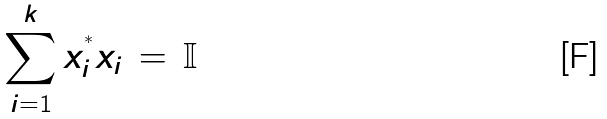<formula> <loc_0><loc_0><loc_500><loc_500>\sum _ { i = 1 } ^ { k } x _ { i } ^ { ^ { * } } x _ { i } \, = \, { \mathbb { I } }</formula> 